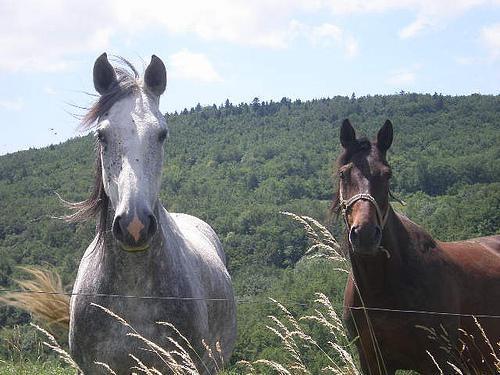How many of the animals are wearing bridles?
Give a very brief answer. 1. How many horses are in the photo?
Give a very brief answer. 2. How many people are wearing a pink and white coat?
Give a very brief answer. 0. 